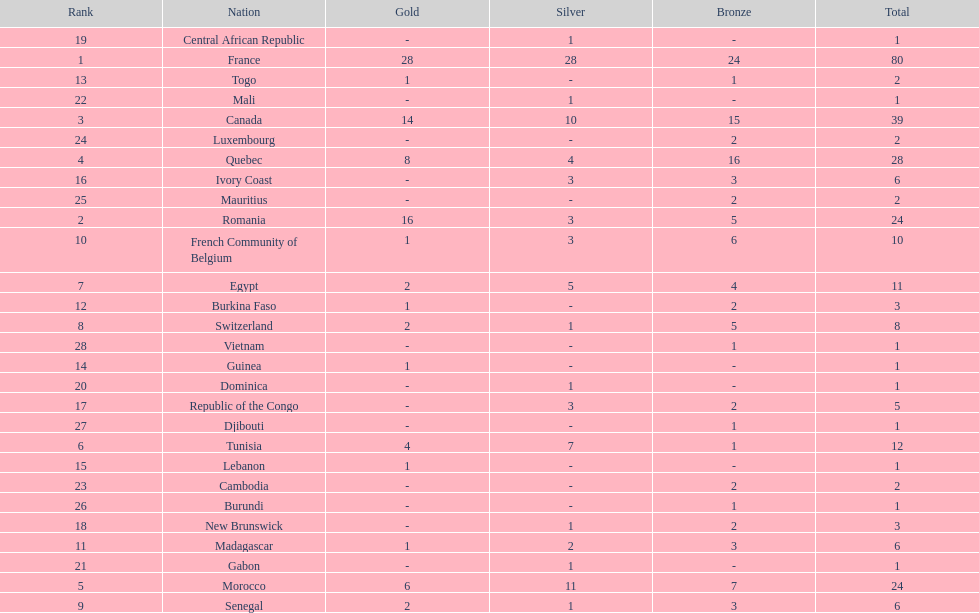How many counties have at least one silver medal? 18. 